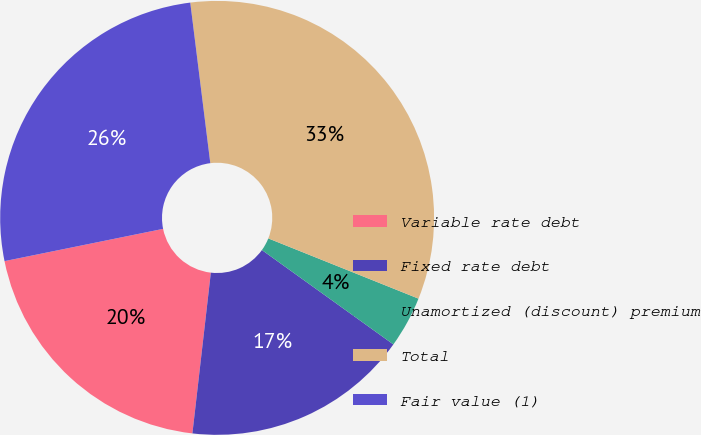<chart> <loc_0><loc_0><loc_500><loc_500><pie_chart><fcel>Variable rate debt<fcel>Fixed rate debt<fcel>Unamortized (discount) premium<fcel>Total<fcel>Fair value (1)<nl><fcel>19.99%<fcel>16.91%<fcel>3.84%<fcel>33.05%<fcel>26.22%<nl></chart> 